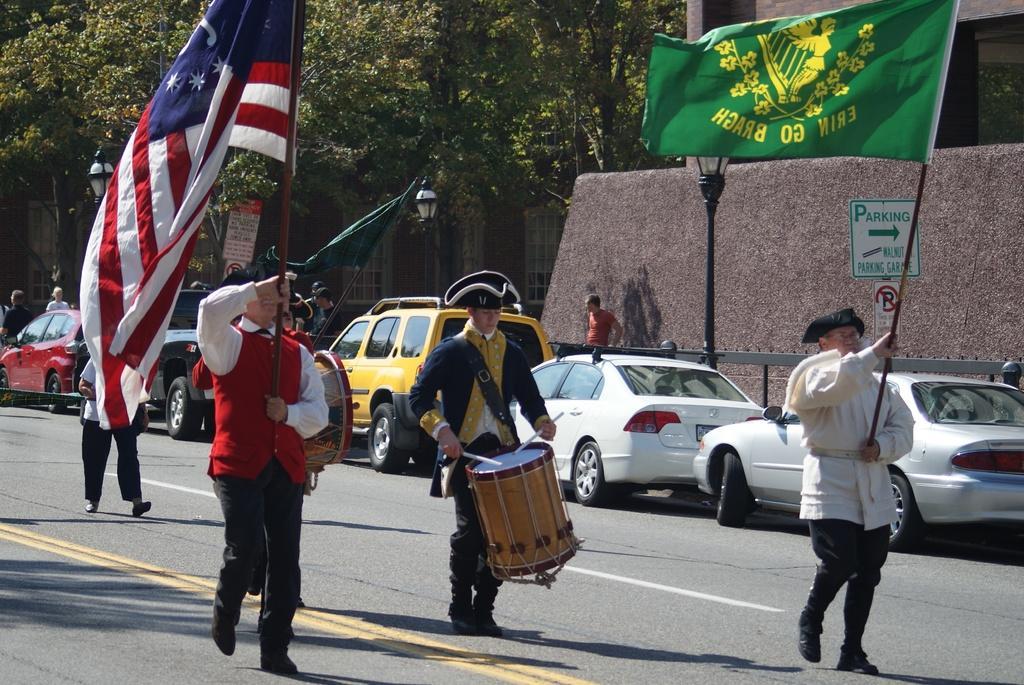How would you summarize this image in a sentence or two? On the background we can see trees, building with windows. These are street lights. We can see vehicles on the road here. We can see persons holding flags in their hands and walking,. We can see this man playing drums. We can see few persons standing near to this fence. 